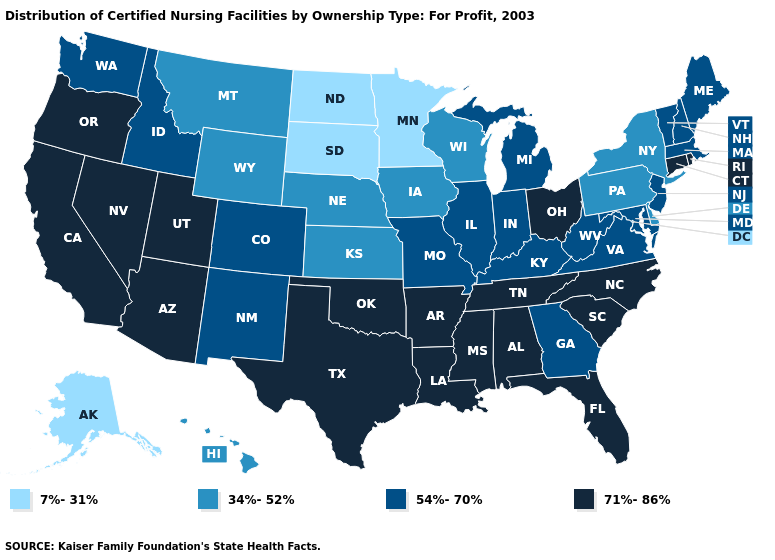What is the value of Rhode Island?
Write a very short answer. 71%-86%. Does the first symbol in the legend represent the smallest category?
Give a very brief answer. Yes. What is the lowest value in the USA?
Quick response, please. 7%-31%. What is the value of Oregon?
Concise answer only. 71%-86%. Name the states that have a value in the range 71%-86%?
Answer briefly. Alabama, Arizona, Arkansas, California, Connecticut, Florida, Louisiana, Mississippi, Nevada, North Carolina, Ohio, Oklahoma, Oregon, Rhode Island, South Carolina, Tennessee, Texas, Utah. Name the states that have a value in the range 71%-86%?
Quick response, please. Alabama, Arizona, Arkansas, California, Connecticut, Florida, Louisiana, Mississippi, Nevada, North Carolina, Ohio, Oklahoma, Oregon, Rhode Island, South Carolina, Tennessee, Texas, Utah. Among the states that border Florida , which have the lowest value?
Concise answer only. Georgia. Name the states that have a value in the range 71%-86%?
Answer briefly. Alabama, Arizona, Arkansas, California, Connecticut, Florida, Louisiana, Mississippi, Nevada, North Carolina, Ohio, Oklahoma, Oregon, Rhode Island, South Carolina, Tennessee, Texas, Utah. What is the value of North Carolina?
Write a very short answer. 71%-86%. Does Nevada have the lowest value in the USA?
Write a very short answer. No. Name the states that have a value in the range 54%-70%?
Short answer required. Colorado, Georgia, Idaho, Illinois, Indiana, Kentucky, Maine, Maryland, Massachusetts, Michigan, Missouri, New Hampshire, New Jersey, New Mexico, Vermont, Virginia, Washington, West Virginia. Among the states that border South Carolina , which have the lowest value?
Give a very brief answer. Georgia. What is the value of Utah?
Write a very short answer. 71%-86%. What is the lowest value in the USA?
Give a very brief answer. 7%-31%. 